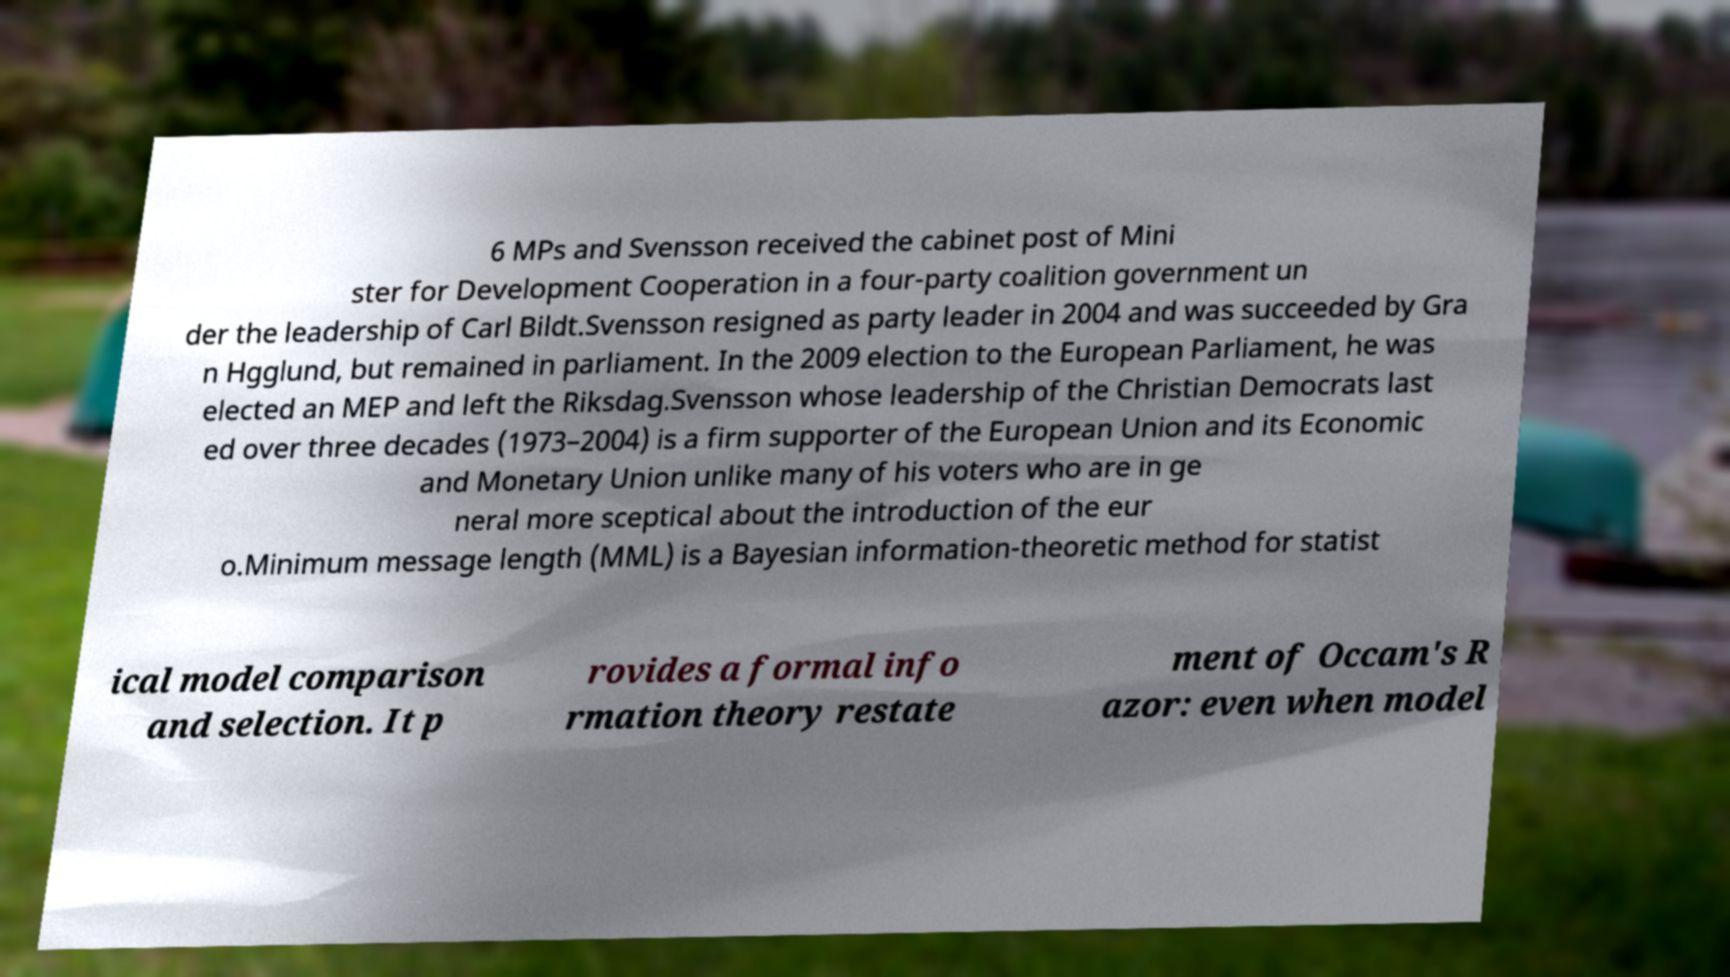Can you accurately transcribe the text from the provided image for me? 6 MPs and Svensson received the cabinet post of Mini ster for Development Cooperation in a four-party coalition government un der the leadership of Carl Bildt.Svensson resigned as party leader in 2004 and was succeeded by Gra n Hgglund, but remained in parliament. In the 2009 election to the European Parliament, he was elected an MEP and left the Riksdag.Svensson whose leadership of the Christian Democrats last ed over three decades (1973–2004) is a firm supporter of the European Union and its Economic and Monetary Union unlike many of his voters who are in ge neral more sceptical about the introduction of the eur o.Minimum message length (MML) is a Bayesian information-theoretic method for statist ical model comparison and selection. It p rovides a formal info rmation theory restate ment of Occam's R azor: even when model 